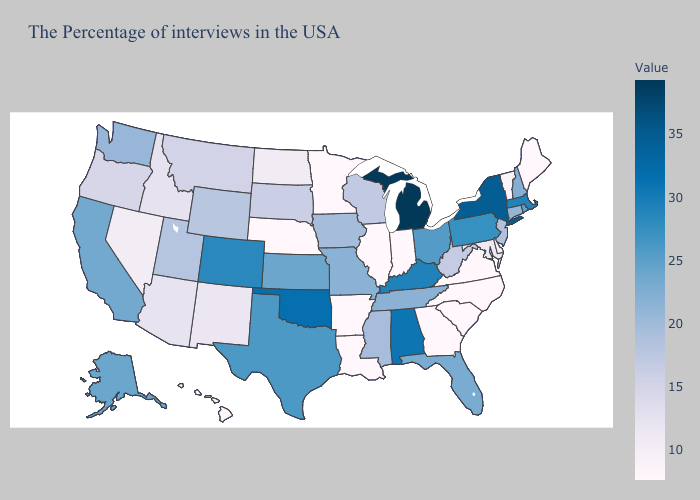Does Tennessee have the lowest value in the USA?
Short answer required. No. Which states hav the highest value in the MidWest?
Write a very short answer. Michigan. Does New Mexico have the lowest value in the West?
Give a very brief answer. No. Which states have the highest value in the USA?
Concise answer only. Michigan. Among the states that border South Carolina , which have the highest value?
Short answer required. North Carolina, Georgia. Does Louisiana have the lowest value in the USA?
Quick response, please. Yes. Which states have the lowest value in the West?
Be succinct. Hawaii. 